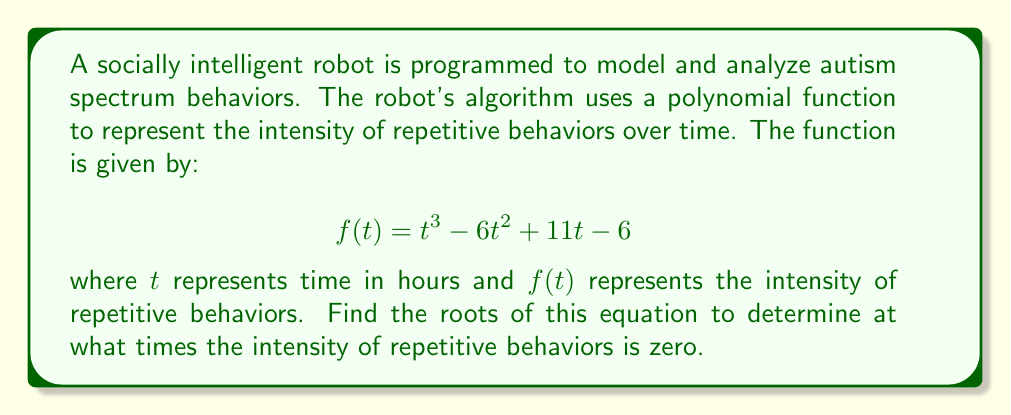Teach me how to tackle this problem. To find the roots of the polynomial equation $f(t) = t^3 - 6t^2 + 11t - 6 = 0$, we need to factor the polynomial. Let's approach this step-by-step:

1) First, let's check if there are any rational roots using the rational root theorem. The possible rational roots are the factors of the constant term (6): ±1, ±2, ±3, ±6.

2) By testing these values, we find that $t = 1$ is a root of the equation.

3) Using polynomial long division or synthetic division, we can divide $f(t)$ by $(t - 1)$:

   $t^3 - 6t^2 + 11t - 6 = (t - 1)(t^2 - 5t + 6)$

4) Now we need to factor the quadratic term $t^2 - 5t + 6$. We can do this by finding two numbers that multiply to give 6 and add to give -5. These numbers are -2 and -3.

5) Therefore, we can factor the quadratic term as $(t - 2)(t - 3)$.

6) The fully factored polynomial is:

   $f(t) = (t - 1)(t - 2)(t - 3)$

7) The roots of the equation are the values of $t$ that make each factor equal to zero. Therefore, the roots are $t = 1$, $t = 2$, and $t = 3$.

These roots represent the times (in hours) when the intensity of repetitive behaviors is zero according to the model.
Answer: The roots of the equation are $t = 1$, $t = 2$, and $t = 3$. 